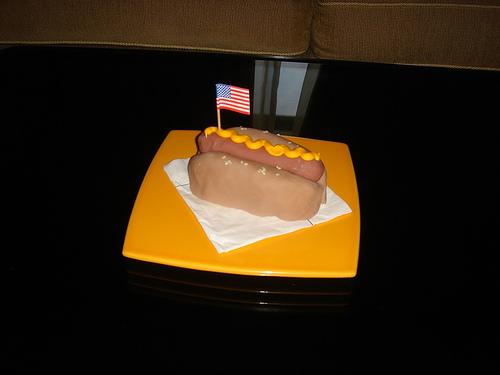What nationality of flag?
Concise answer only. America. What food is this supposed to be?
Short answer required. Hot dog. What color is the plate?
Quick response, please. Yellow. 